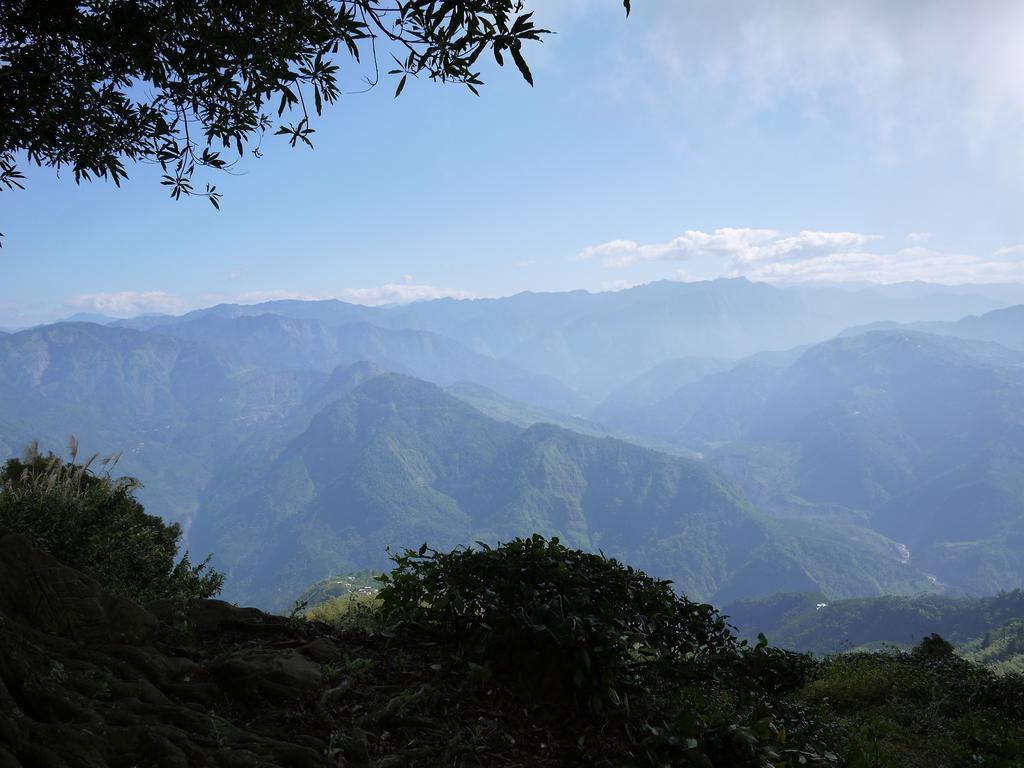Can you describe this image briefly? In this image I see the leaves over here and I see the plants. In the background I see the mountains and the sky. 